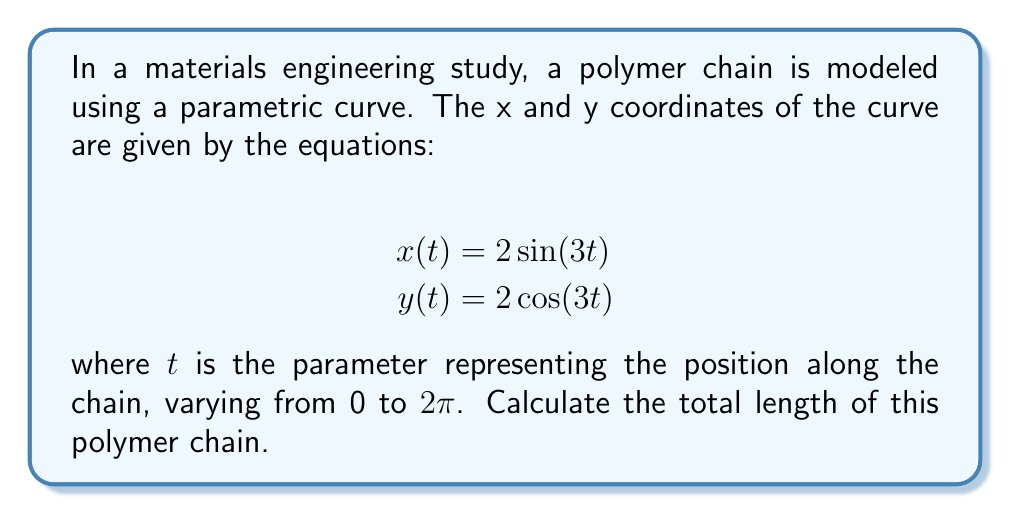Show me your answer to this math problem. To find the length of the parametric curve, we need to use the arc length formula:

$$L = \int_{a}^{b} \sqrt{\left(\frac{dx}{dt}\right)^2 + \left(\frac{dy}{dt}\right)^2} dt$$

Where $a$ and $b$ are the lower and upper bounds of the parameter $t$.

1) First, let's find $\frac{dx}{dt}$ and $\frac{dy}{dt}$:

   $$\frac{dx}{dt} = 6\cos(3t)$$
   $$\frac{dy}{dt} = -6\sin(3t)$$

2) Now, let's substitute these into the arc length formula:

   $$L = \int_{0}^{2\pi} \sqrt{(6\cos(3t))^2 + (-6\sin(3t))^2} dt$$

3) Simplify under the square root:

   $$L = \int_{0}^{2\pi} \sqrt{36\cos^2(3t) + 36\sin^2(3t)} dt$$

4) Use the trigonometric identity $\cos^2\theta + \sin^2\theta = 1$:

   $$L = \int_{0}^{2\pi} \sqrt{36(\cos^2(3t) + \sin^2(3t))} dt$$
   $$L = \int_{0}^{2\pi} \sqrt{36} dt$$
   $$L = \int_{0}^{2\pi} 6 dt$$

5) Integrate:

   $$L = 6t \bigg|_{0}^{2\pi}$$
   $$L = 6(2\pi) - 6(0) = 12\pi$$

Therefore, the total length of the polymer chain is $12\pi$ units.
Answer: $12\pi$ units 